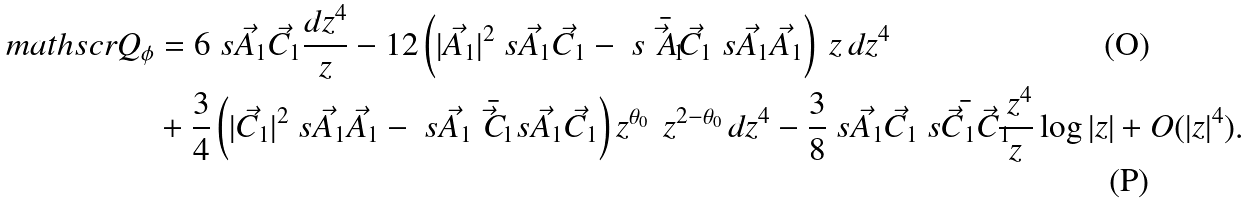<formula> <loc_0><loc_0><loc_500><loc_500>\ m a t h s c r { Q } _ { \phi } & = 6 \ s { \vec { A } _ { 1 } } { \vec { C } _ { 1 } } \frac { d z ^ { 4 } } { z } - 1 2 \left ( | \vec { A } _ { 1 } | ^ { 2 } \ s { \vec { A } _ { 1 } } { \vec { C } _ { 1 } } - \ s { \bar { \vec { A } _ { 1 } } } { \vec { C } _ { 1 } } \ s { \vec { A } _ { 1 } } { \vec { A } _ { 1 } } \right ) \ z \, d z ^ { 4 } \\ & + \frac { 3 } { 4 } \left ( | \vec { C } _ { 1 } | ^ { 2 } \ s { \vec { A } _ { 1 } } { \vec { A } _ { 1 } } - \ s { \vec { A } _ { 1 } } { \bar { \vec { C } _ { 1 } } } \ s { \vec { A } _ { 1 } } { \vec { C } _ { 1 } } \right ) z ^ { \theta _ { 0 } } \, \ z ^ { 2 - \theta _ { 0 } } \, d z ^ { 4 } - \frac { 3 } { 8 } \ s { \vec { A } _ { 1 } } { \vec { C } _ { 1 } } \bar { \ s { \vec { C } _ { 1 } } { \vec { C } _ { 1 } } } \frac { \ z ^ { 4 } } { z } \log | z | + O ( | z | ^ { 4 } ) .</formula> 